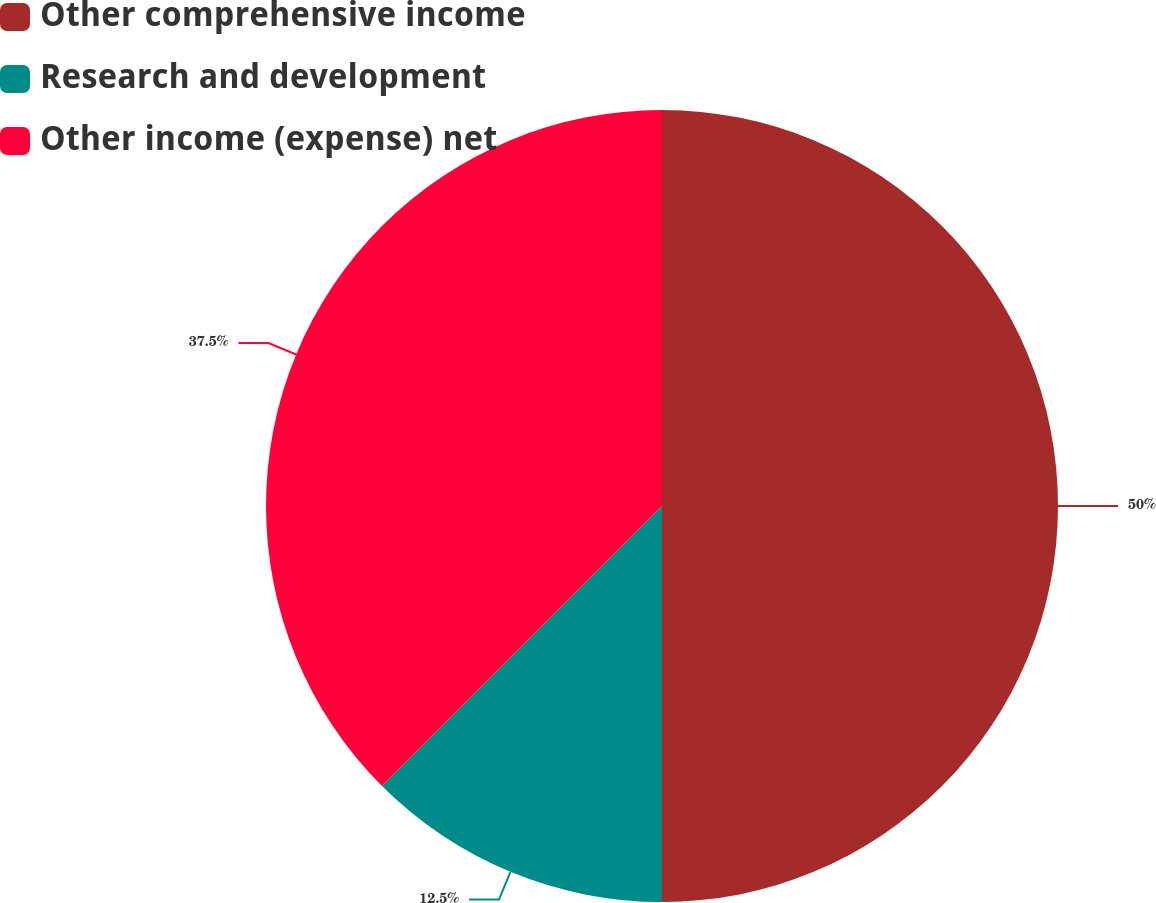<chart> <loc_0><loc_0><loc_500><loc_500><pie_chart><fcel>Other comprehensive income<fcel>Research and development<fcel>Other income (expense) net<nl><fcel>50.0%<fcel>12.5%<fcel>37.5%<nl></chart> 